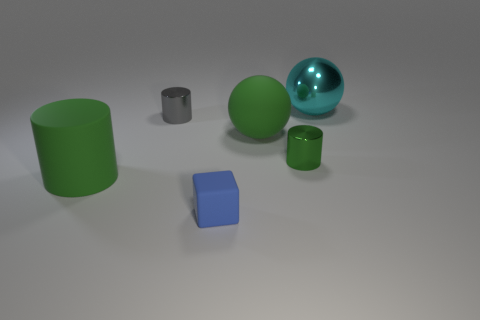The blue thing that is made of the same material as the large green cylinder is what shape?
Ensure brevity in your answer.  Cube. Are there more tiny green cylinders to the left of the large green rubber cylinder than big cyan objects that are behind the large cyan metal ball?
Provide a short and direct response. No. How many objects are either small blue metal cylinders or green rubber cylinders?
Your answer should be very brief. 1. What number of other objects are the same color as the block?
Provide a succinct answer. 0. The green thing that is the same size as the cube is what shape?
Your response must be concise. Cylinder. What color is the cylinder right of the blue matte block?
Ensure brevity in your answer.  Green. How many things are either large things in front of the tiny green cylinder or things to the right of the small block?
Provide a succinct answer. 4. Is the size of the green ball the same as the cyan thing?
Offer a very short reply. Yes. How many balls are big brown objects or blue matte things?
Keep it short and to the point. 0. What number of green rubber objects are to the left of the blue thing and behind the matte cylinder?
Ensure brevity in your answer.  0. 